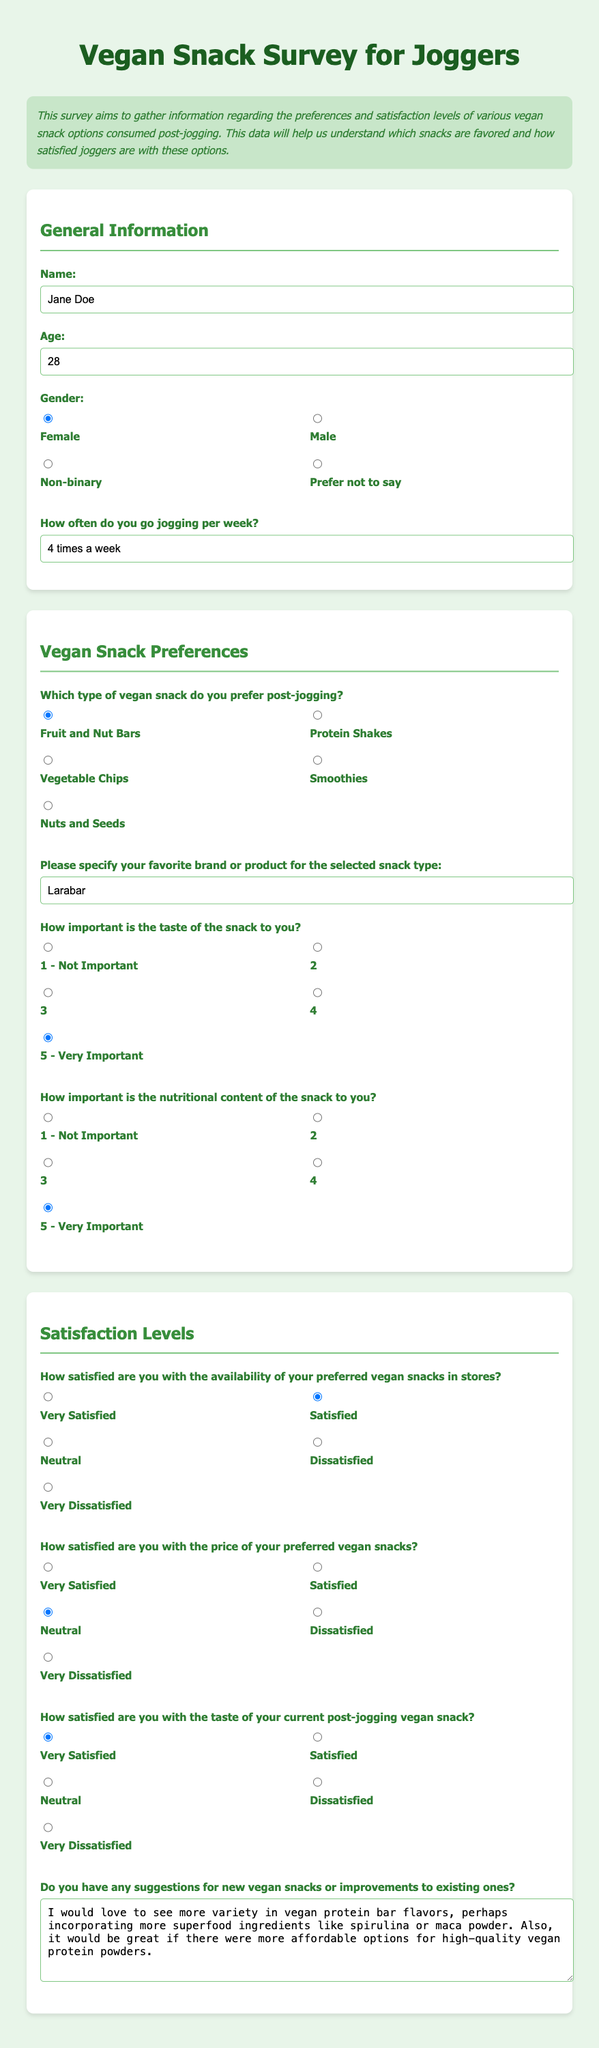What is the name of the survey participant? The name field is filled with "Jane Doe" in the document.
Answer: Jane Doe How old is the survey participant? The age field specifies that the participant is "28" years old.
Answer: 28 What type of vegan snack does the participant prefer post-jogging? The preferred snack type indicated is "Fruit and Nut Bars."
Answer: Fruit and Nut Bars What is the participant's favorite brand for the selected snack type? The favorite brand mentioned is "Larabar."
Answer: Larabar How important is the taste of the snack to the participant? The participant rated taste importance as "5 - Very Important."
Answer: 5 - Very Important How satisfied is the participant with the availability of vegan snacks in stores? The satisfaction level is marked as "Satisfied."
Answer: Satisfied What is the participant’s satisfaction level with the price of vegan snacks? The survey shows the participant is "Neutral" regarding the price satisfaction.
Answer: Neutral What suggestions does the participant have for vegan snacks? The participant's suggestions include "more variety in vegan protein bar flavors."
Answer: more variety in vegan protein bar flavors How often does the participant go jogging per week? The participant jogs "4 times a week."
Answer: 4 times a week 